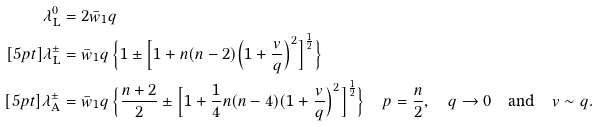Convert formula to latex. <formula><loc_0><loc_0><loc_500><loc_500>\lambda ^ { 0 } _ { \text {L} } & = 2 \bar { w } _ { 1 } q \\ [ 5 p t ] \lambda ^ { \pm } _ { \text {L} } & = \bar { w } _ { 1 } q \, \Big \{ 1 \pm \Big [ 1 + n ( n - 2 ) \Big ( 1 + \frac { v } { q } \Big ) ^ { 2 } \Big ] ^ { \frac { 1 } { 2 } } \Big \} \\ [ 5 p t ] \lambda ^ { \pm } _ { \text {A} } & = \bar { w } _ { 1 } q \, \Big \{ \frac { n + 2 } { 2 } \pm \Big [ 1 + \frac { 1 } { 4 } n ( n - 4 ) ( 1 + \frac { v } { q } \Big ) ^ { 2 } \Big ] ^ { \frac { 1 } { 2 } } \Big \} \quad p = \frac { n } { 2 } , \quad q \to 0 \quad \text {and} \quad v \sim q .</formula> 